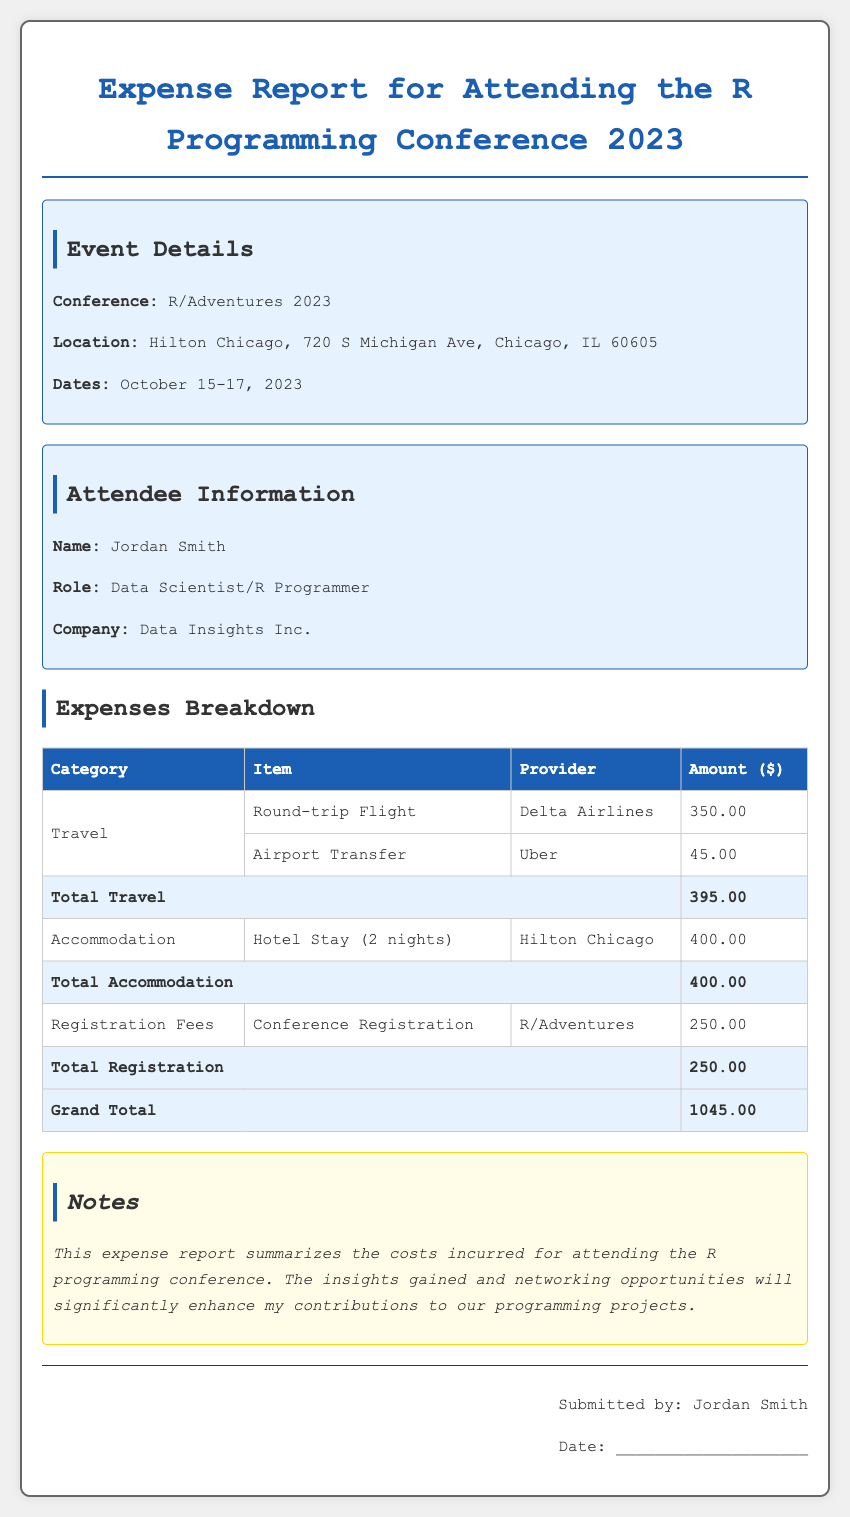What is the name of the conference? The document provides the name of the conference, which is mentioned in the event details section.
Answer: R/Adventures 2023 Who is the attendee? The document contains attendee information and lists the name of the individual who submitted the expense report.
Answer: Jordan Smith How much was the round-trip flight? The expense breakdown table specifies the amount for the round-trip flight under the travel category.
Answer: 350.00 What is the total amount for accommodation? The total for accommodation is provided in the expense breakdown table, summarizing hotel stay costs.
Answer: 400.00 How many nights was the hotel stay? The expense report indicates the duration of the hotel stay in the accommodation section.
Answer: 2 nights What is the grand total of expenses? The document concludes with a summary of all expenses, including travel, accommodation, and registration fees, leading to the grand total.
Answer: 1045.00 What type of transportation was used for airport transfer? The breakdown specifies the type of service used for airport transfer under the travel category.
Answer: Uber What is the provider for the registration fees? The document lists the provider associated with the conference registration in the expenses breakdown.
Answer: R/Adventures What date was the expense report submitted? The expense report includes a signature line that indicates where the author would provide the submission date.
Answer: ____________________ 